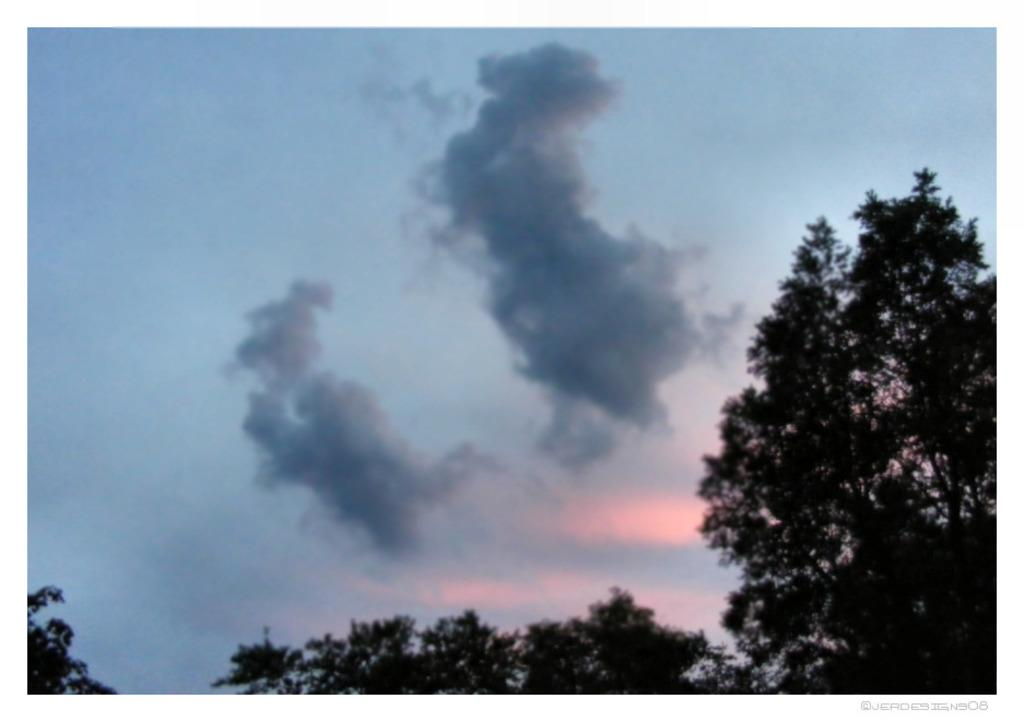What type of vegetation is present at the bottom of the image? There are trees at the bottom of the image. What can be seen in the sky at the top of the image? There are clouds in the sky at the top of the image. What type of stitch is used to create the clouds in the image? There is no stitching involved in the image, as the clouds are a natural phenomenon in the sky. How does the cannon contribute to the overall composition of the image? There is no cannon present in the image, so it cannot contribute to the composition. 